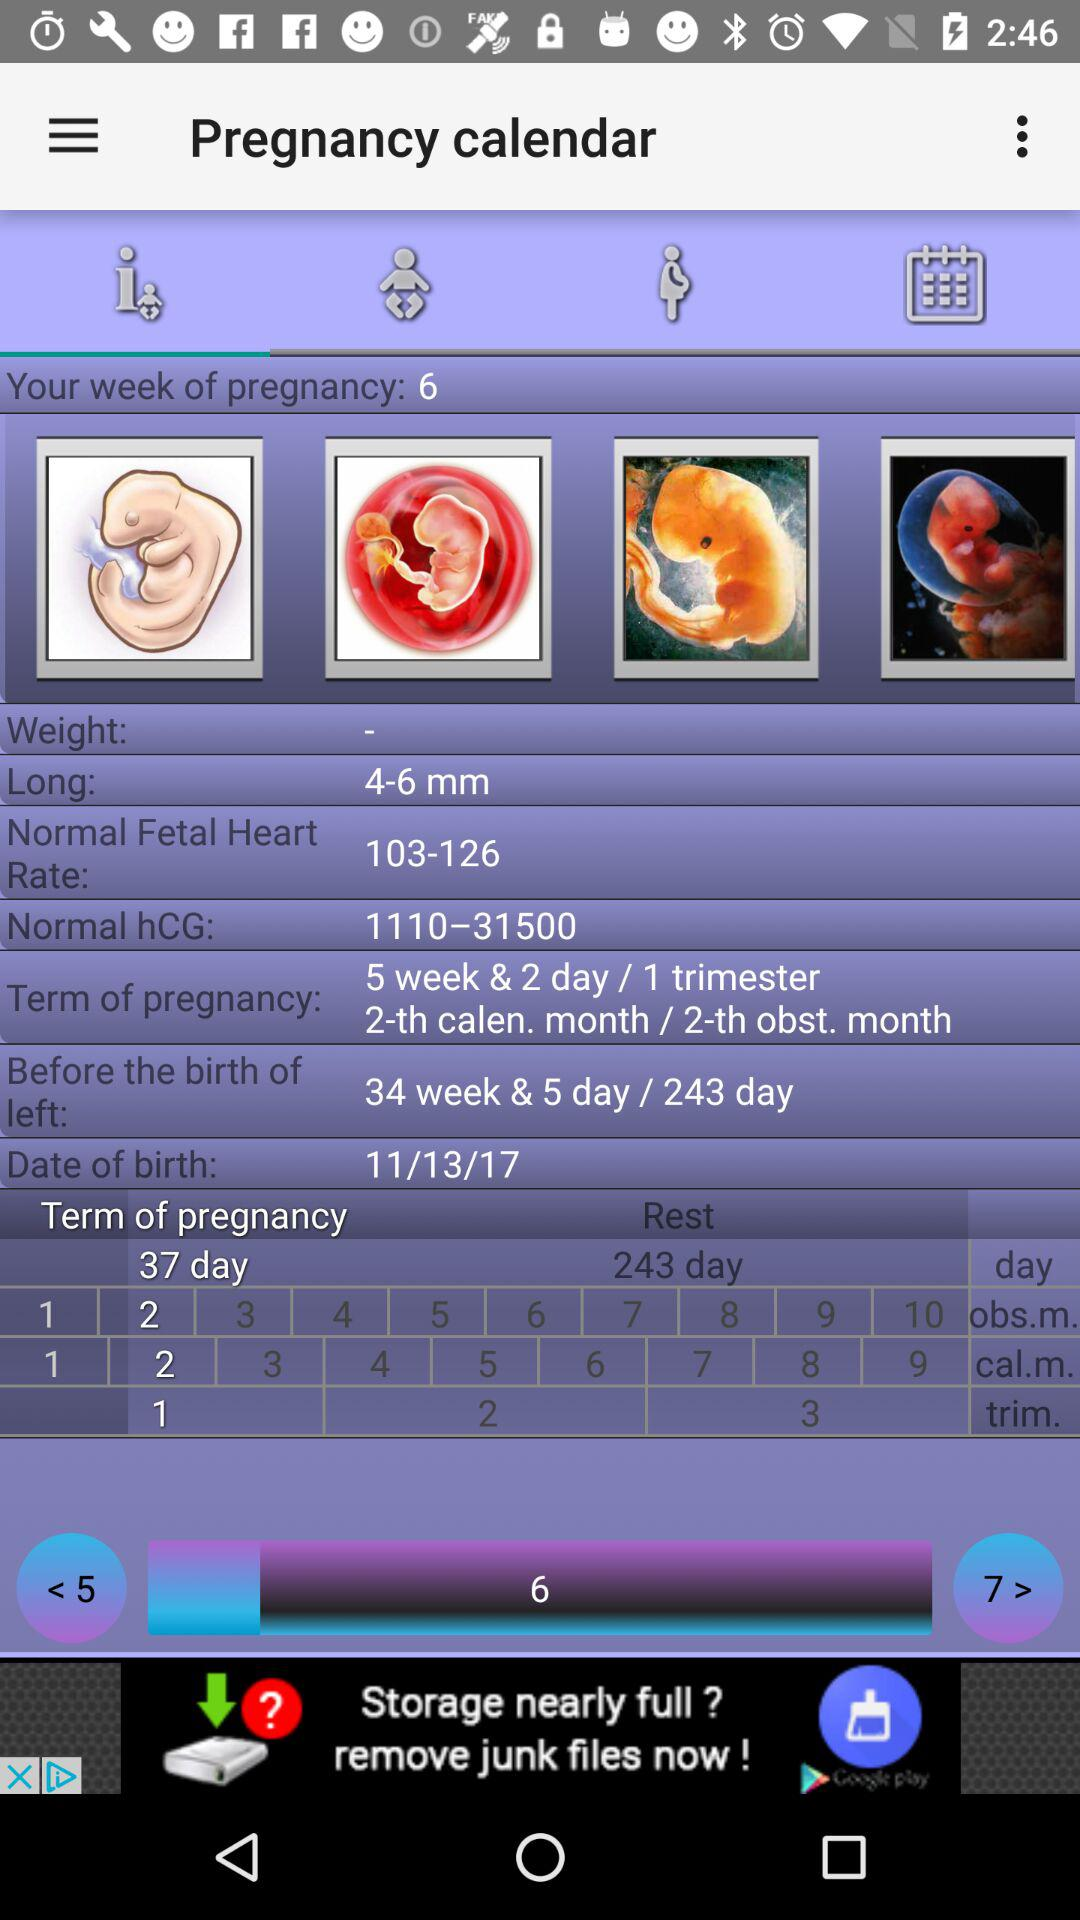What is the date of birth? The date of birth is 11/13/17. 